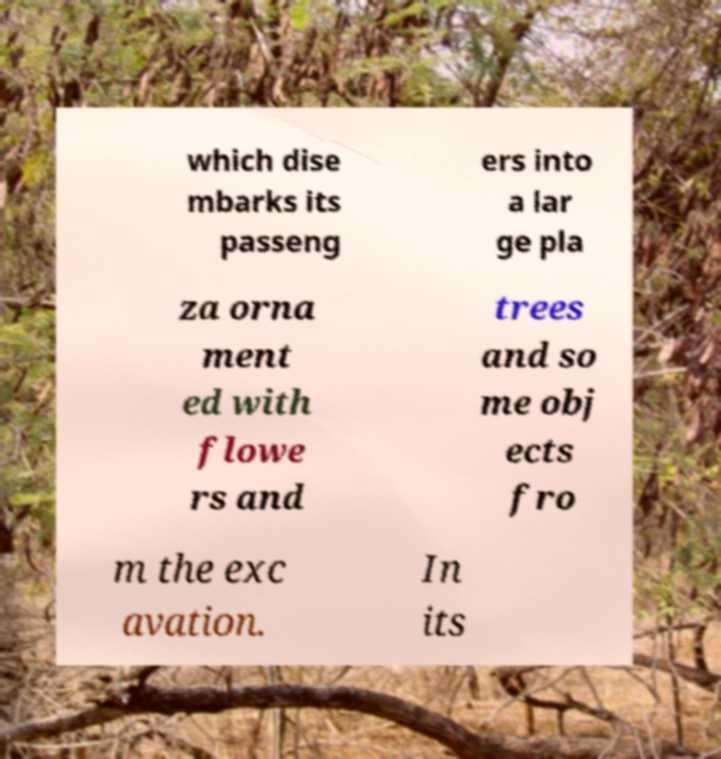Please read and relay the text visible in this image. What does it say? which dise mbarks its passeng ers into a lar ge pla za orna ment ed with flowe rs and trees and so me obj ects fro m the exc avation. In its 